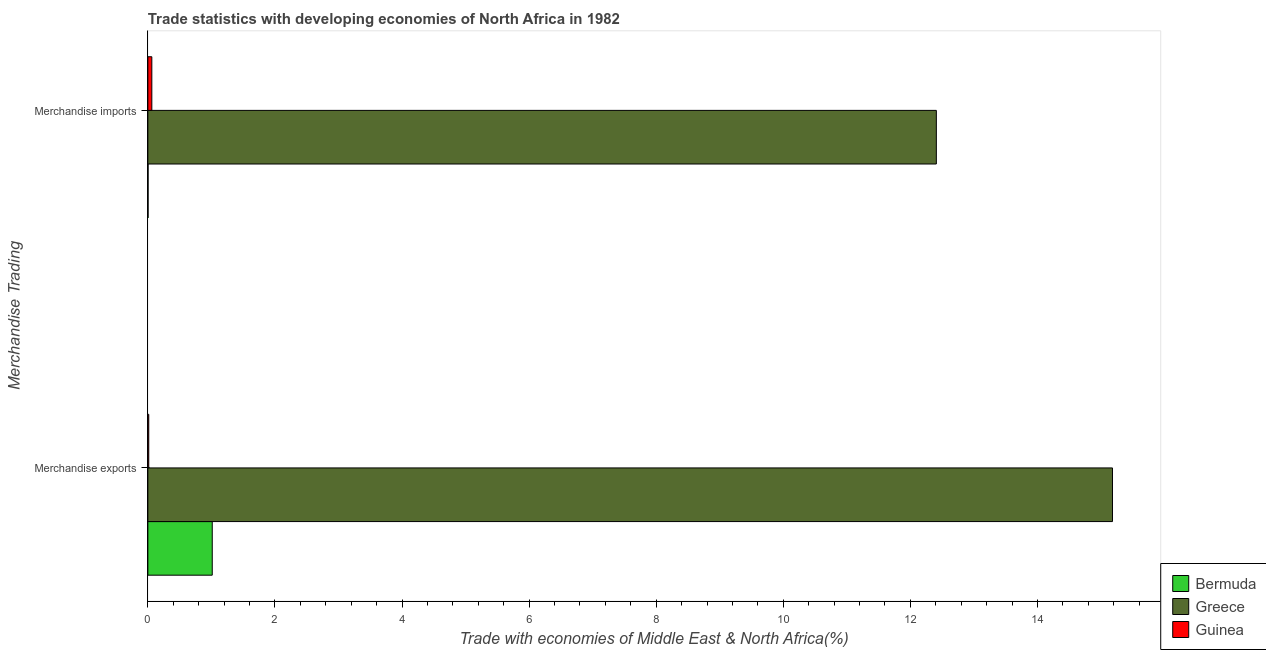How many different coloured bars are there?
Make the answer very short. 3. How many bars are there on the 1st tick from the bottom?
Keep it short and to the point. 3. What is the label of the 1st group of bars from the top?
Give a very brief answer. Merchandise imports. What is the merchandise exports in Guinea?
Offer a terse response. 0.01. Across all countries, what is the maximum merchandise imports?
Offer a terse response. 12.41. Across all countries, what is the minimum merchandise imports?
Provide a succinct answer. 0. In which country was the merchandise exports minimum?
Your answer should be very brief. Guinea. What is the total merchandise exports in the graph?
Offer a very short reply. 16.21. What is the difference between the merchandise exports in Guinea and that in Bermuda?
Provide a succinct answer. -1. What is the difference between the merchandise exports in Bermuda and the merchandise imports in Greece?
Provide a short and direct response. -11.4. What is the average merchandise exports per country?
Your answer should be compact. 5.4. What is the difference between the merchandise exports and merchandise imports in Greece?
Your answer should be compact. 2.77. What is the ratio of the merchandise imports in Guinea to that in Greece?
Provide a short and direct response. 0.01. What does the 3rd bar from the bottom in Merchandise exports represents?
Keep it short and to the point. Guinea. Are all the bars in the graph horizontal?
Provide a succinct answer. Yes. Does the graph contain grids?
Provide a short and direct response. No. What is the title of the graph?
Make the answer very short. Trade statistics with developing economies of North Africa in 1982. Does "Iceland" appear as one of the legend labels in the graph?
Your response must be concise. No. What is the label or title of the X-axis?
Ensure brevity in your answer.  Trade with economies of Middle East & North Africa(%). What is the label or title of the Y-axis?
Give a very brief answer. Merchandise Trading. What is the Trade with economies of Middle East & North Africa(%) in Bermuda in Merchandise exports?
Offer a terse response. 1.01. What is the Trade with economies of Middle East & North Africa(%) of Greece in Merchandise exports?
Offer a very short reply. 15.18. What is the Trade with economies of Middle East & North Africa(%) of Guinea in Merchandise exports?
Offer a very short reply. 0.01. What is the Trade with economies of Middle East & North Africa(%) of Bermuda in Merchandise imports?
Your response must be concise. 0. What is the Trade with economies of Middle East & North Africa(%) of Greece in Merchandise imports?
Ensure brevity in your answer.  12.41. What is the Trade with economies of Middle East & North Africa(%) of Guinea in Merchandise imports?
Keep it short and to the point. 0.06. Across all Merchandise Trading, what is the maximum Trade with economies of Middle East & North Africa(%) in Bermuda?
Give a very brief answer. 1.01. Across all Merchandise Trading, what is the maximum Trade with economies of Middle East & North Africa(%) in Greece?
Your response must be concise. 15.18. Across all Merchandise Trading, what is the maximum Trade with economies of Middle East & North Africa(%) in Guinea?
Your answer should be very brief. 0.06. Across all Merchandise Trading, what is the minimum Trade with economies of Middle East & North Africa(%) of Bermuda?
Ensure brevity in your answer.  0. Across all Merchandise Trading, what is the minimum Trade with economies of Middle East & North Africa(%) in Greece?
Give a very brief answer. 12.41. Across all Merchandise Trading, what is the minimum Trade with economies of Middle East & North Africa(%) of Guinea?
Offer a very short reply. 0.01. What is the total Trade with economies of Middle East & North Africa(%) in Bermuda in the graph?
Ensure brevity in your answer.  1.02. What is the total Trade with economies of Middle East & North Africa(%) in Greece in the graph?
Provide a succinct answer. 27.59. What is the total Trade with economies of Middle East & North Africa(%) in Guinea in the graph?
Provide a succinct answer. 0.08. What is the difference between the Trade with economies of Middle East & North Africa(%) of Greece in Merchandise exports and that in Merchandise imports?
Offer a very short reply. 2.77. What is the difference between the Trade with economies of Middle East & North Africa(%) in Guinea in Merchandise exports and that in Merchandise imports?
Offer a terse response. -0.05. What is the difference between the Trade with economies of Middle East & North Africa(%) in Bermuda in Merchandise exports and the Trade with economies of Middle East & North Africa(%) in Greece in Merchandise imports?
Give a very brief answer. -11.4. What is the difference between the Trade with economies of Middle East & North Africa(%) in Bermuda in Merchandise exports and the Trade with economies of Middle East & North Africa(%) in Guinea in Merchandise imports?
Make the answer very short. 0.95. What is the difference between the Trade with economies of Middle East & North Africa(%) of Greece in Merchandise exports and the Trade with economies of Middle East & North Africa(%) of Guinea in Merchandise imports?
Provide a short and direct response. 15.12. What is the average Trade with economies of Middle East & North Africa(%) of Bermuda per Merchandise Trading?
Keep it short and to the point. 0.51. What is the average Trade with economies of Middle East & North Africa(%) in Greece per Merchandise Trading?
Your response must be concise. 13.79. What is the average Trade with economies of Middle East & North Africa(%) of Guinea per Merchandise Trading?
Your answer should be compact. 0.04. What is the difference between the Trade with economies of Middle East & North Africa(%) in Bermuda and Trade with economies of Middle East & North Africa(%) in Greece in Merchandise exports?
Offer a very short reply. -14.17. What is the difference between the Trade with economies of Middle East & North Africa(%) of Bermuda and Trade with economies of Middle East & North Africa(%) of Guinea in Merchandise exports?
Make the answer very short. 1. What is the difference between the Trade with economies of Middle East & North Africa(%) in Greece and Trade with economies of Middle East & North Africa(%) in Guinea in Merchandise exports?
Keep it short and to the point. 15.17. What is the difference between the Trade with economies of Middle East & North Africa(%) of Bermuda and Trade with economies of Middle East & North Africa(%) of Greece in Merchandise imports?
Make the answer very short. -12.41. What is the difference between the Trade with economies of Middle East & North Africa(%) in Bermuda and Trade with economies of Middle East & North Africa(%) in Guinea in Merchandise imports?
Offer a very short reply. -0.06. What is the difference between the Trade with economies of Middle East & North Africa(%) of Greece and Trade with economies of Middle East & North Africa(%) of Guinea in Merchandise imports?
Ensure brevity in your answer.  12.35. What is the ratio of the Trade with economies of Middle East & North Africa(%) of Bermuda in Merchandise exports to that in Merchandise imports?
Offer a very short reply. 326.37. What is the ratio of the Trade with economies of Middle East & North Africa(%) in Greece in Merchandise exports to that in Merchandise imports?
Provide a short and direct response. 1.22. What is the ratio of the Trade with economies of Middle East & North Africa(%) in Guinea in Merchandise exports to that in Merchandise imports?
Your answer should be compact. 0.22. What is the difference between the highest and the second highest Trade with economies of Middle East & North Africa(%) of Bermuda?
Keep it short and to the point. 1.01. What is the difference between the highest and the second highest Trade with economies of Middle East & North Africa(%) in Greece?
Give a very brief answer. 2.77. What is the difference between the highest and the second highest Trade with economies of Middle East & North Africa(%) in Guinea?
Make the answer very short. 0.05. What is the difference between the highest and the lowest Trade with economies of Middle East & North Africa(%) in Greece?
Your answer should be very brief. 2.77. What is the difference between the highest and the lowest Trade with economies of Middle East & North Africa(%) in Guinea?
Ensure brevity in your answer.  0.05. 